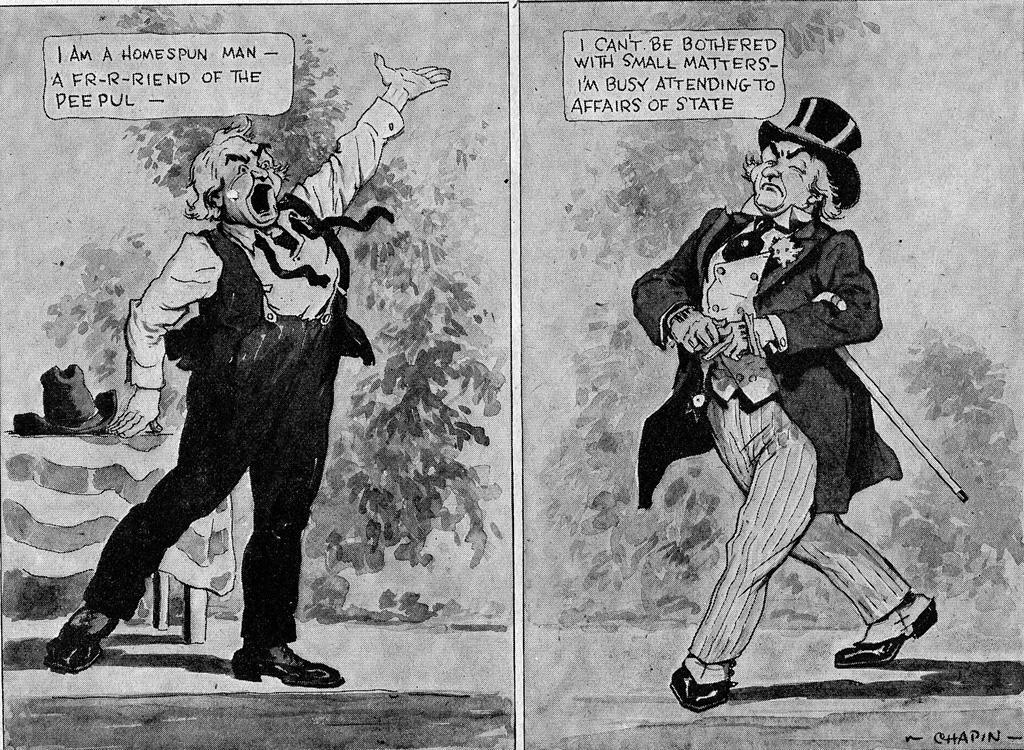What type of image is being described? The image is a collage. What can be found within the collage? There are pictures of a cartoon in the image. Are there any words or phrases related to the cartoon in the image? Yes, there is text of a cartoon in the image. Can you see a rabbit eating a pancake in the image? There is no rabbit or pancake present in the image; it is a collage featuring pictures and text of a cartoon. Is there a washing machine in the image? There is no washing machine present in the image. 